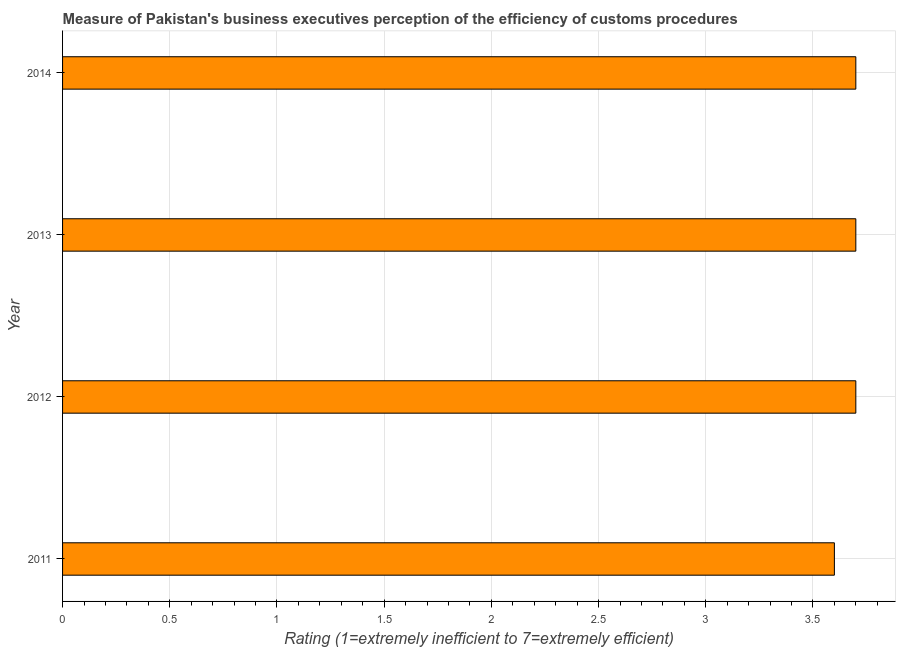Does the graph contain any zero values?
Offer a terse response. No. What is the title of the graph?
Ensure brevity in your answer.  Measure of Pakistan's business executives perception of the efficiency of customs procedures. What is the label or title of the X-axis?
Provide a short and direct response. Rating (1=extremely inefficient to 7=extremely efficient). Across all years, what is the maximum rating measuring burden of customs procedure?
Ensure brevity in your answer.  3.7. Across all years, what is the minimum rating measuring burden of customs procedure?
Ensure brevity in your answer.  3.6. In which year was the rating measuring burden of customs procedure minimum?
Your response must be concise. 2011. What is the average rating measuring burden of customs procedure per year?
Your answer should be compact. 3.67. In how many years, is the rating measuring burden of customs procedure greater than 1.1 ?
Ensure brevity in your answer.  4. Do a majority of the years between 2014 and 2013 (inclusive) have rating measuring burden of customs procedure greater than 1.7 ?
Provide a short and direct response. No. Is the rating measuring burden of customs procedure in 2011 less than that in 2014?
Your response must be concise. Yes. What is the difference between the highest and the second highest rating measuring burden of customs procedure?
Provide a short and direct response. 0. What is the difference between the highest and the lowest rating measuring burden of customs procedure?
Your response must be concise. 0.1. Are all the bars in the graph horizontal?
Your answer should be very brief. Yes. What is the difference between two consecutive major ticks on the X-axis?
Offer a terse response. 0.5. Are the values on the major ticks of X-axis written in scientific E-notation?
Provide a succinct answer. No. What is the Rating (1=extremely inefficient to 7=extremely efficient) in 2011?
Your answer should be very brief. 3.6. What is the Rating (1=extremely inefficient to 7=extremely efficient) in 2012?
Provide a short and direct response. 3.7. What is the Rating (1=extremely inefficient to 7=extremely efficient) in 2014?
Offer a terse response. 3.7. What is the difference between the Rating (1=extremely inefficient to 7=extremely efficient) in 2011 and 2012?
Offer a terse response. -0.1. What is the difference between the Rating (1=extremely inefficient to 7=extremely efficient) in 2012 and 2013?
Provide a short and direct response. 0. What is the difference between the Rating (1=extremely inefficient to 7=extremely efficient) in 2012 and 2014?
Your answer should be compact. 0. What is the ratio of the Rating (1=extremely inefficient to 7=extremely efficient) in 2011 to that in 2013?
Provide a short and direct response. 0.97. What is the ratio of the Rating (1=extremely inefficient to 7=extremely efficient) in 2012 to that in 2013?
Offer a terse response. 1. What is the ratio of the Rating (1=extremely inefficient to 7=extremely efficient) in 2012 to that in 2014?
Keep it short and to the point. 1. 